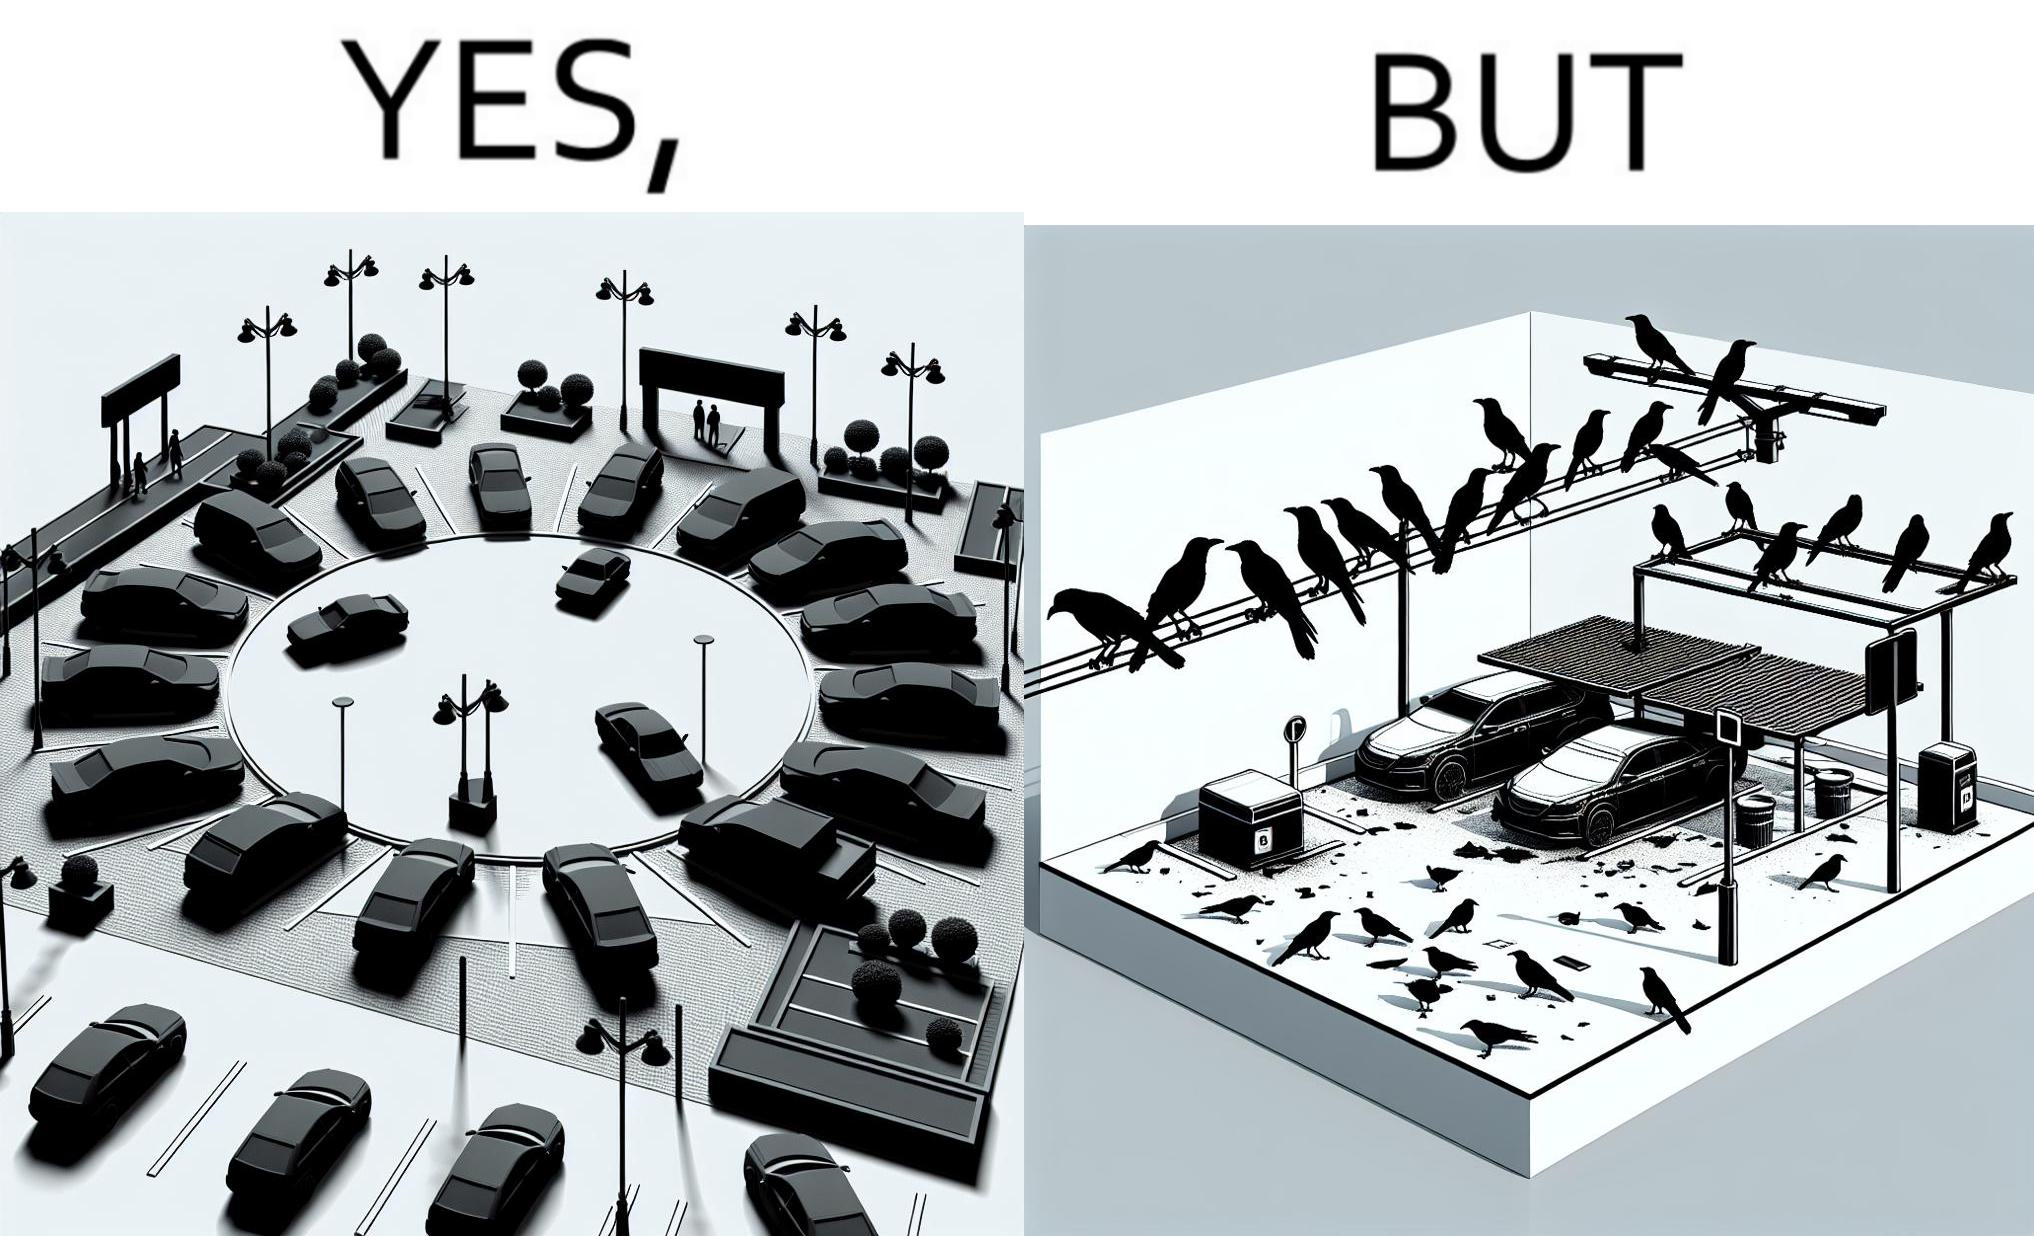Does this image contain satire or humor? Yes, this image is satirical. 